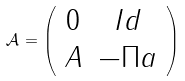Convert formula to latex. <formula><loc_0><loc_0><loc_500><loc_500>\mathcal { A } = \left ( \begin{array} { c c } 0 & I d \\ A & - \Pi a \end{array} \right )</formula> 